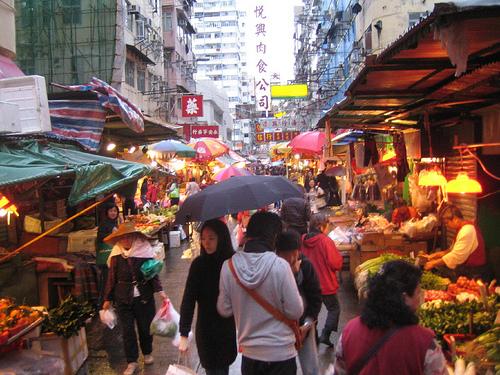Is this a street market?
Be succinct. Yes. Could one say that some of these items show a fine line between beauty and garishness?
Quick response, please. No. Are the umbrellas colorful?
Write a very short answer. Yes. What race are these people?
Be succinct. Asian. Is this a city?
Write a very short answer. Yes. 